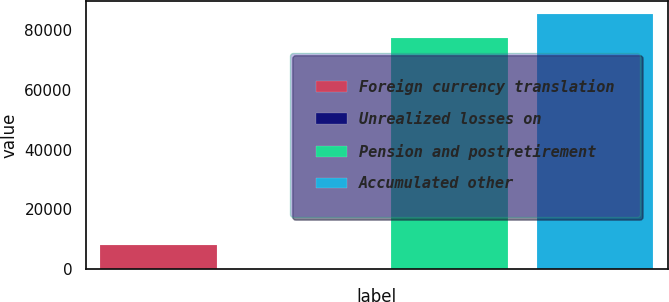Convert chart to OTSL. <chart><loc_0><loc_0><loc_500><loc_500><bar_chart><fcel>Foreign currency translation<fcel>Unrealized losses on<fcel>Pension and postretirement<fcel>Accumulated other<nl><fcel>8150.4<fcel>110<fcel>77318<fcel>85358.4<nl></chart> 